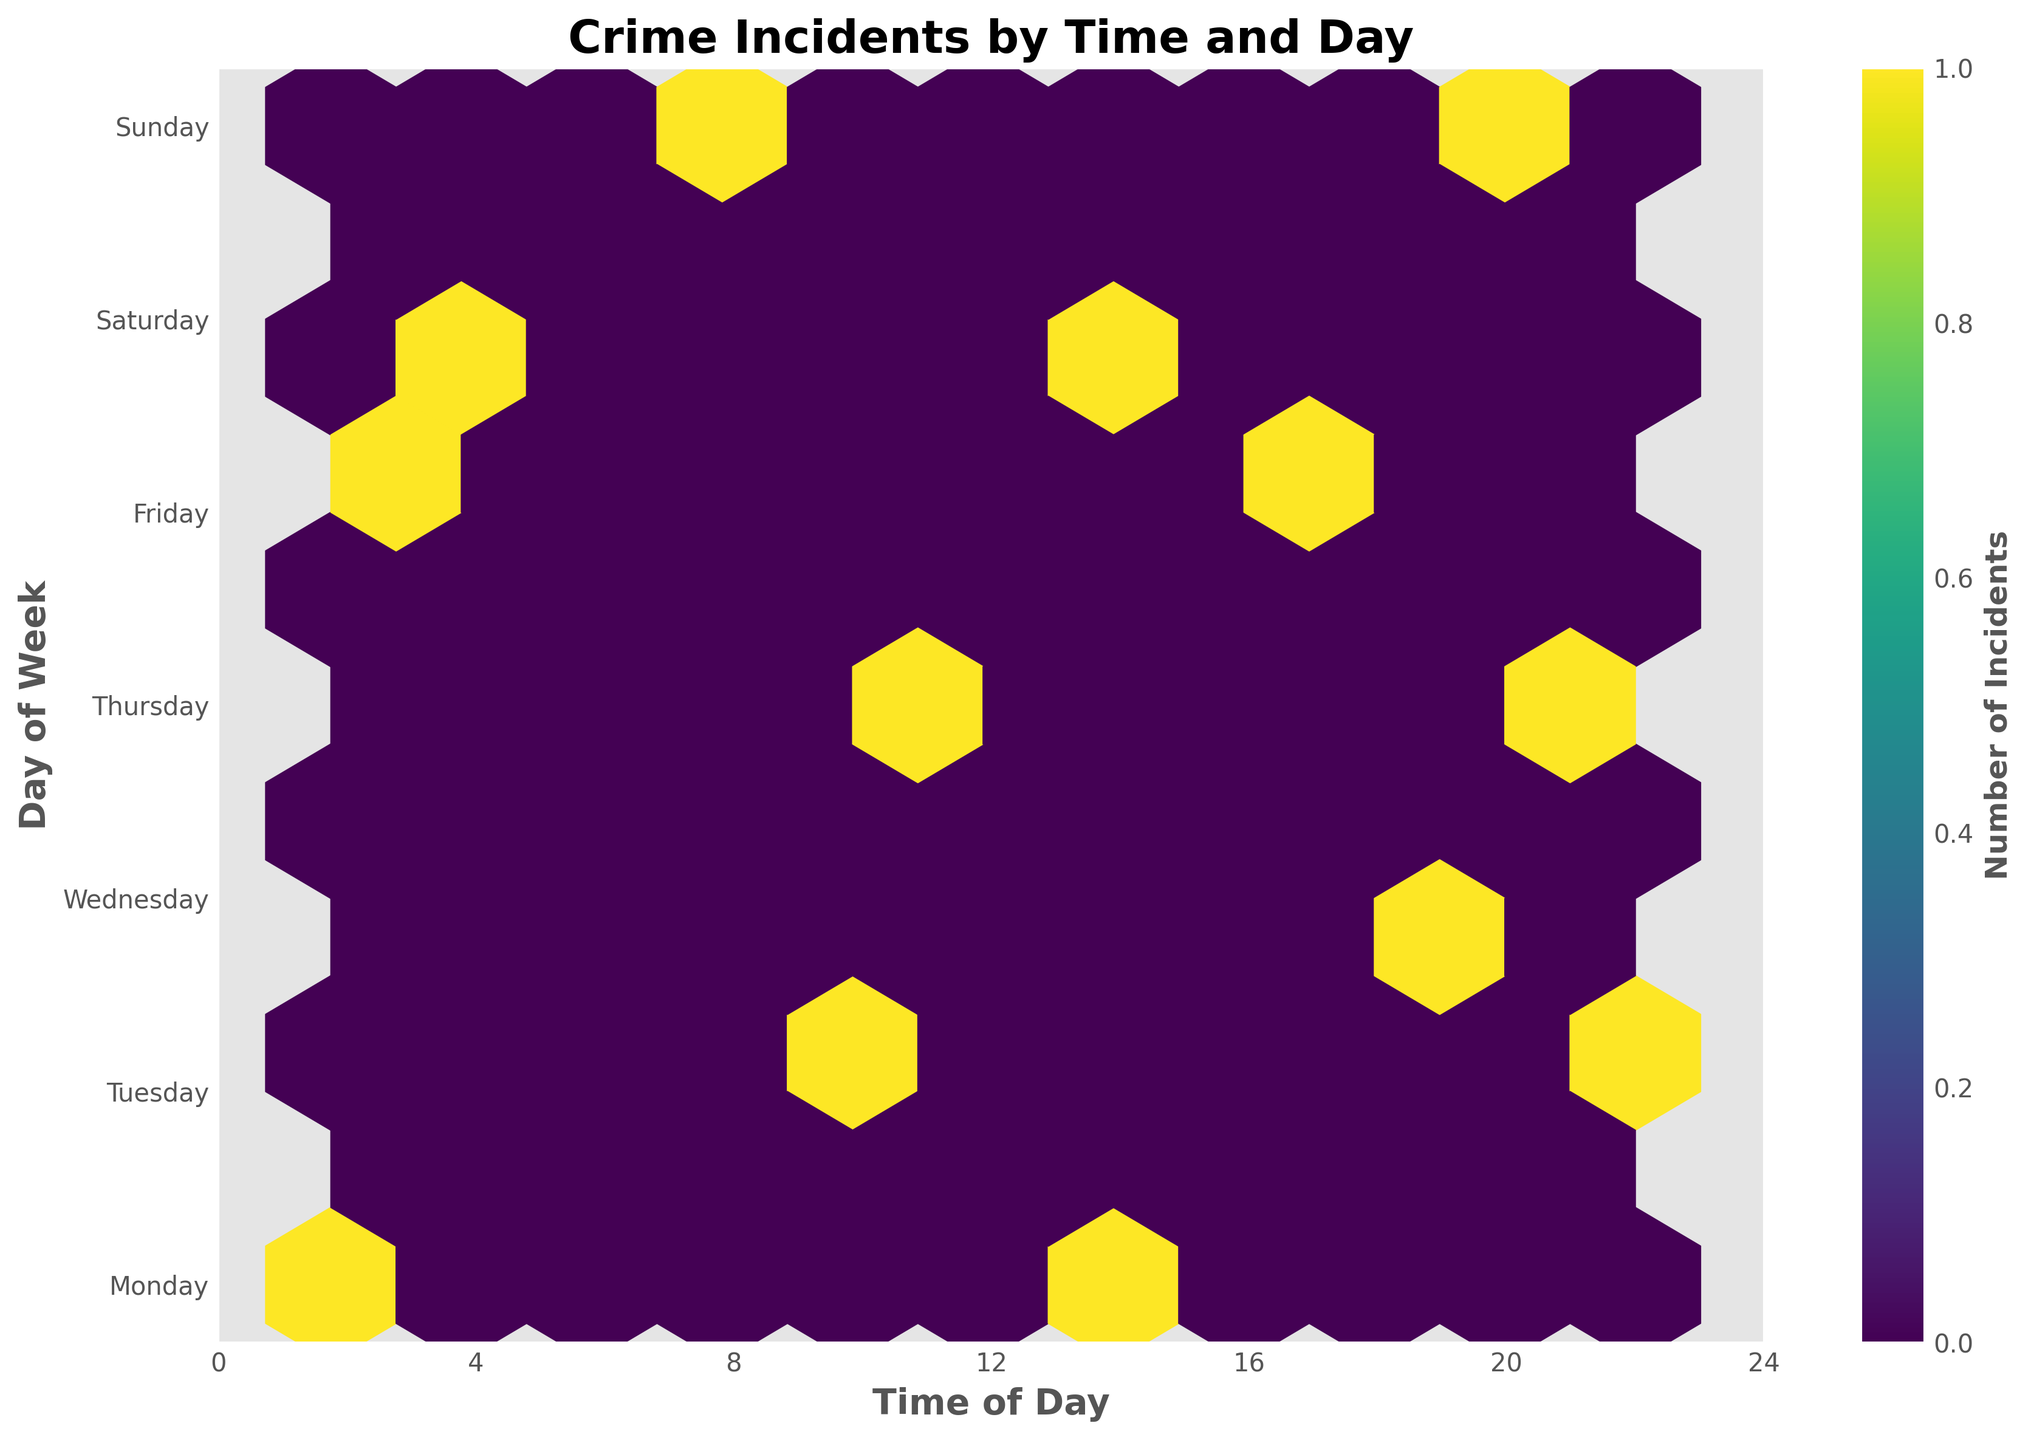What types of incidents are shown on this plot? The plot title is 'Crime Incidents by Time and Day', and the crime incidents mentioned in the data include Vandalism, Theft, Suspicious Person, Noise Complaint, Burglary, Public Intoxication, Domestic Dispute, Assault, Shoplifting, DUI, Missing Person, Car Break-in, and Drug Activity.
Answer: Various crime incidents such as Vandalism, Theft, and Burglary are shown When do most of the crime incidents occur? We look for the areas with the highest concentration (densest color) of hexagons on the plot. The x-axis represents time and the y-axis represents days.
Answer: In the evenings and late at night Which day of the week has the highest number of incidents? Compare the color intensity of hexagons vertically along each day of the week. The darker or denser the hexagons, the more incidents on that day.
Answer: Friday Are there any days with notably fewer incidents? Observe the hexagons that are lightest in color or fewer in number across each day.
Answer: Sunday During which time of the day is crime least likely to occur? Identify the regions on the time axis (x-axis) with the fewest or lightest hexagons.
Answer: Early morning hours (e.g., around 5-6 AM) Do specific types of incidents cluster around certain times more than others? This question requires identifying distinct clusters or dense hexagons and correlating them with the incident types mentioned in the data.
Answer: Yes, specific types do cluster. For example, DUI incidents are typically late at night or early morning How many incidents happen late at night compared to midday? Compare the density of hexagons in the late night hours (e.g., after 10 PM) to midday hours (e.g., around 12 PM - 1 PM).
Answer: More incidents occur late at night Which day of the week has incidents distributed most evenly throughout the day? Look for a day where the hexagons are spread relatively uniformly across the time axis.
Answer: Wednesday Is there a significant difference in incident numbers between weekdays and weekends? Compare the cumulative density of hexagons on weekdays (Monday to Friday) versus weekends (Saturday and Sunday).
Answer: Yes, there are generally more incidents on weekdays Is there a specific time range where incidents spike for multiple days? Look for consistent dense hexagon patterns appearing at similar times across different days.
Answer: Late afternoon to evening hours (e.g., 6 PM to 8 PM) 